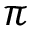<formula> <loc_0><loc_0><loc_500><loc_500>\pi</formula> 